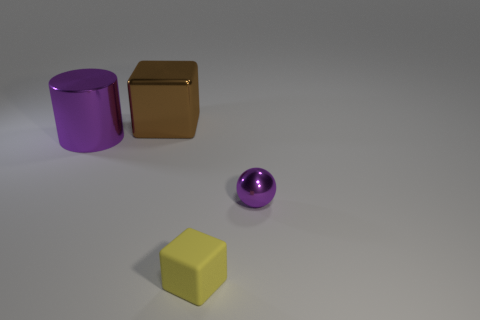Subtract 1 cubes. How many cubes are left? 1 Add 1 small green metal cylinders. How many objects exist? 5 Subtract all yellow blocks. How many blocks are left? 1 Subtract all green blocks. Subtract all gray spheres. How many blocks are left? 2 Subtract all gray cylinders. How many brown cubes are left? 1 Add 3 metal balls. How many metal balls are left? 4 Add 3 big purple shiny objects. How many big purple shiny objects exist? 4 Subtract 0 blue cylinders. How many objects are left? 4 Subtract all spheres. How many objects are left? 3 Subtract all large purple things. Subtract all green matte blocks. How many objects are left? 3 